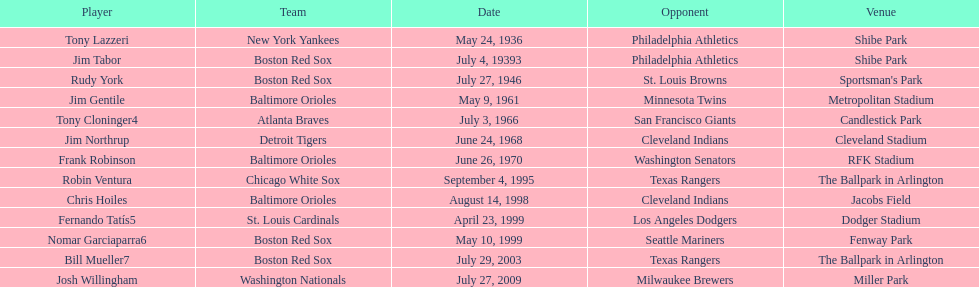Can you name all the participating teams? New York Yankees, Boston Red Sox, Boston Red Sox, Baltimore Orioles, Atlanta Braves, Detroit Tigers, Baltimore Orioles, Chicago White Sox, Baltimore Orioles, St. Louis Cardinals, Boston Red Sox, Boston Red Sox, Washington Nationals. Who were they competing against? Philadelphia Athletics, Philadelphia Athletics, St. Louis Browns, Minnesota Twins, San Francisco Giants, Cleveland Indians, Washington Senators, Texas Rangers, Cleveland Indians, Los Angeles Dodgers, Seattle Mariners, Texas Rangers, Milwaukee Brewers. What were the dates of the games? May 24, 1936, July 4, 19393, July 27, 1946, May 9, 1961, July 3, 1966, June 24, 1968, June 26, 1970, September 4, 1995, August 14, 1998, April 23, 1999, May 10, 1999, July 29, 2003, July 27, 2009. Which team went up against the red sox on july 27, 1946? St. Louis Browns. 